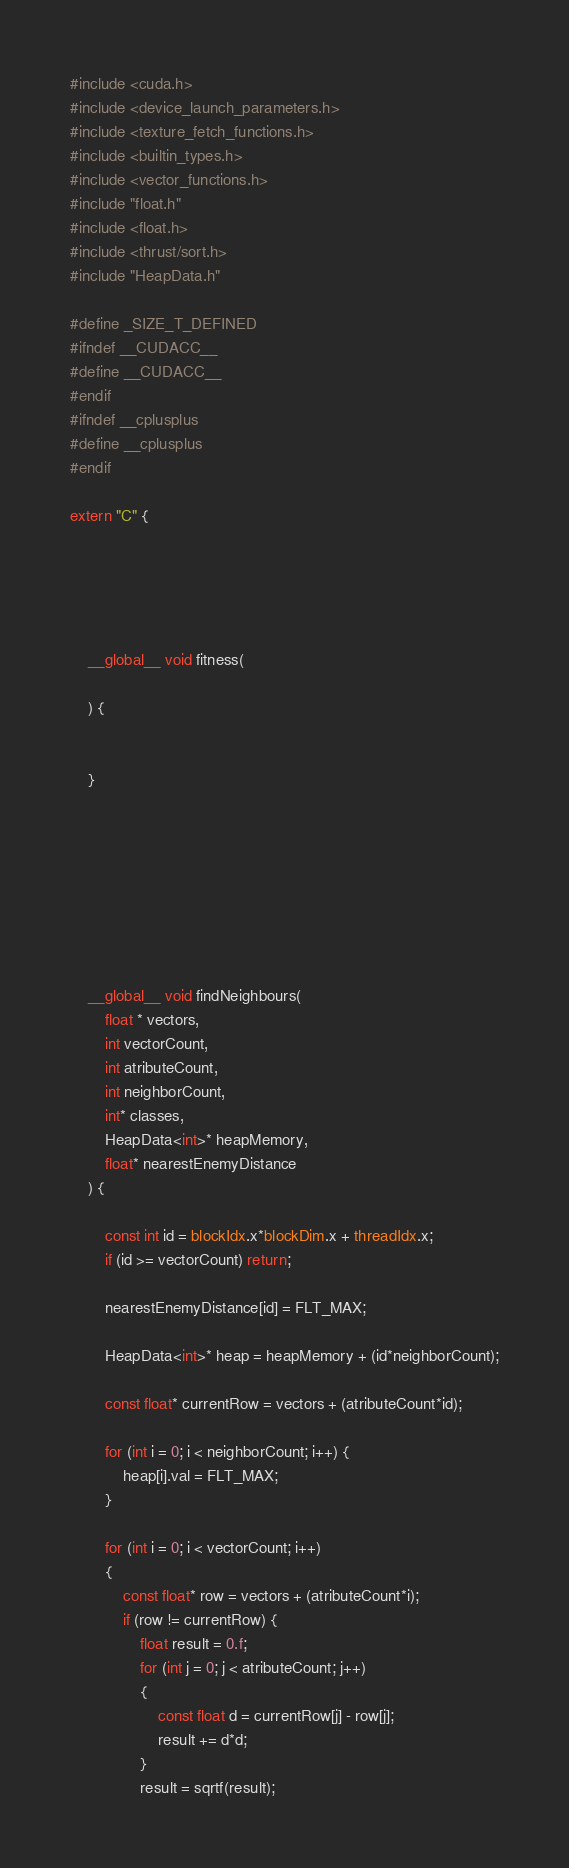<code> <loc_0><loc_0><loc_500><loc_500><_Cuda_>#include <cuda.h> 
#include <device_launch_parameters.h> 
#include <texture_fetch_functions.h> 
#include <builtin_types.h> 
#include <vector_functions.h> 
#include "float.h"
#include <float.h>
#include <thrust/sort.h>
#include "HeapData.h"

#define _SIZE_T_DEFINED 
#ifndef __CUDACC__ 
#define __CUDACC__ 
#endif 
#ifndef __cplusplus 
#define __cplusplus 
#endif

extern "C" {





	__global__ void fitness(
	
	) {
	
	
	}








	__global__ void findNeighbours(
		float * vectors,
		int vectorCount,
		int atributeCount,
		int neighborCount,
		int* classes,
		HeapData<int>* heapMemory,
		float* nearestEnemyDistance
	) {

		const int id = blockIdx.x*blockDim.x + threadIdx.x;
		if (id >= vectorCount) return;

		nearestEnemyDistance[id] = FLT_MAX;

		HeapData<int>* heap = heapMemory + (id*neighborCount);

		const float* currentRow = vectors + (atributeCount*id);

		for (int i = 0; i < neighborCount; i++) {
			heap[i].val = FLT_MAX;
		}

		for (int i = 0; i < vectorCount; i++)
		{
			const float* row = vectors + (atributeCount*i);
			if (row != currentRow) {
				float result = 0.f;
				for (int j = 0; j < atributeCount; j++)
				{
					const float d = currentRow[j] - row[j];
					result += d*d;
				}
				result = sqrtf(result);
</code> 